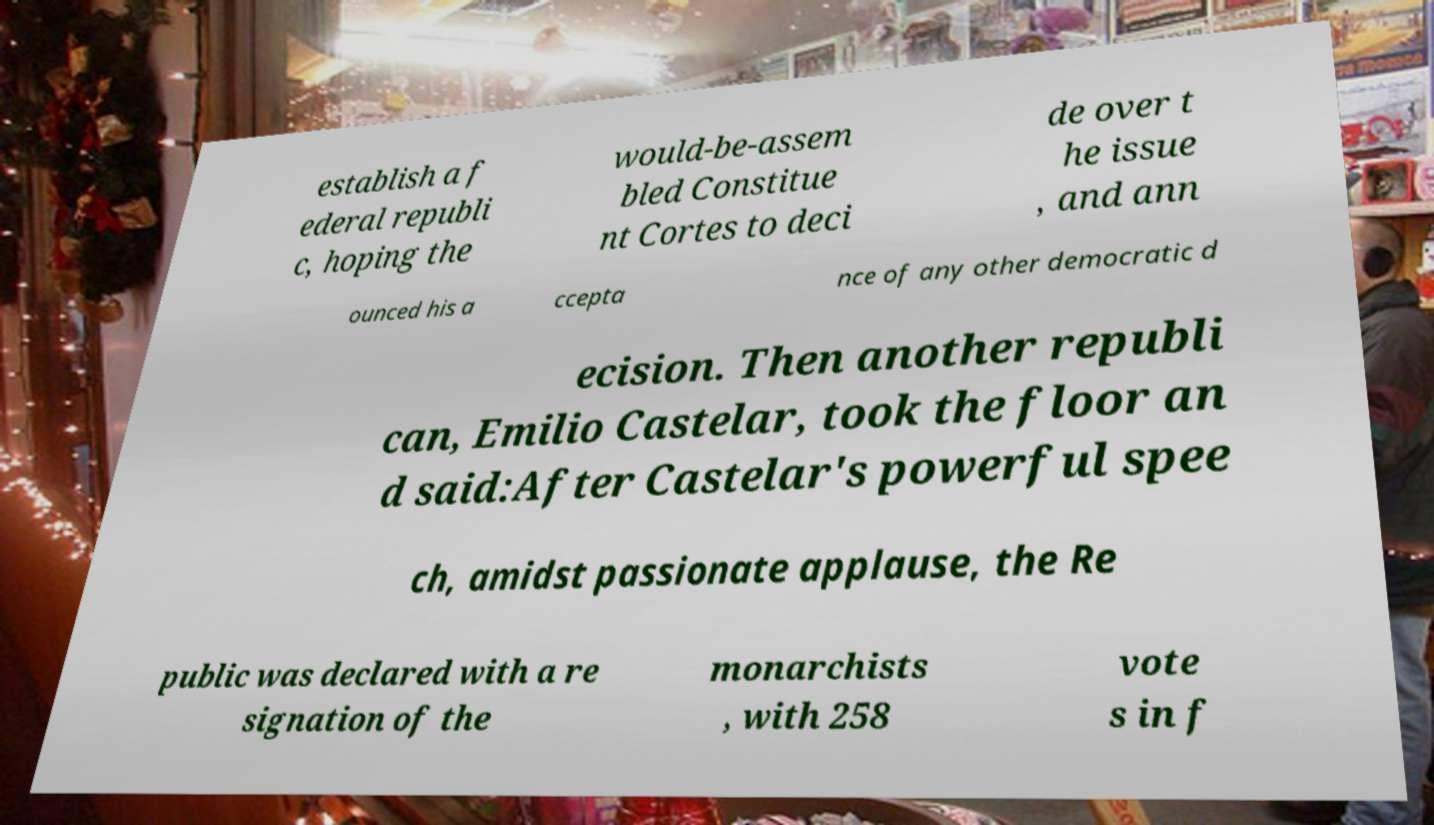Can you read and provide the text displayed in the image?This photo seems to have some interesting text. Can you extract and type it out for me? establish a f ederal republi c, hoping the would-be-assem bled Constitue nt Cortes to deci de over t he issue , and ann ounced his a ccepta nce of any other democratic d ecision. Then another republi can, Emilio Castelar, took the floor an d said:After Castelar's powerful spee ch, amidst passionate applause, the Re public was declared with a re signation of the monarchists , with 258 vote s in f 